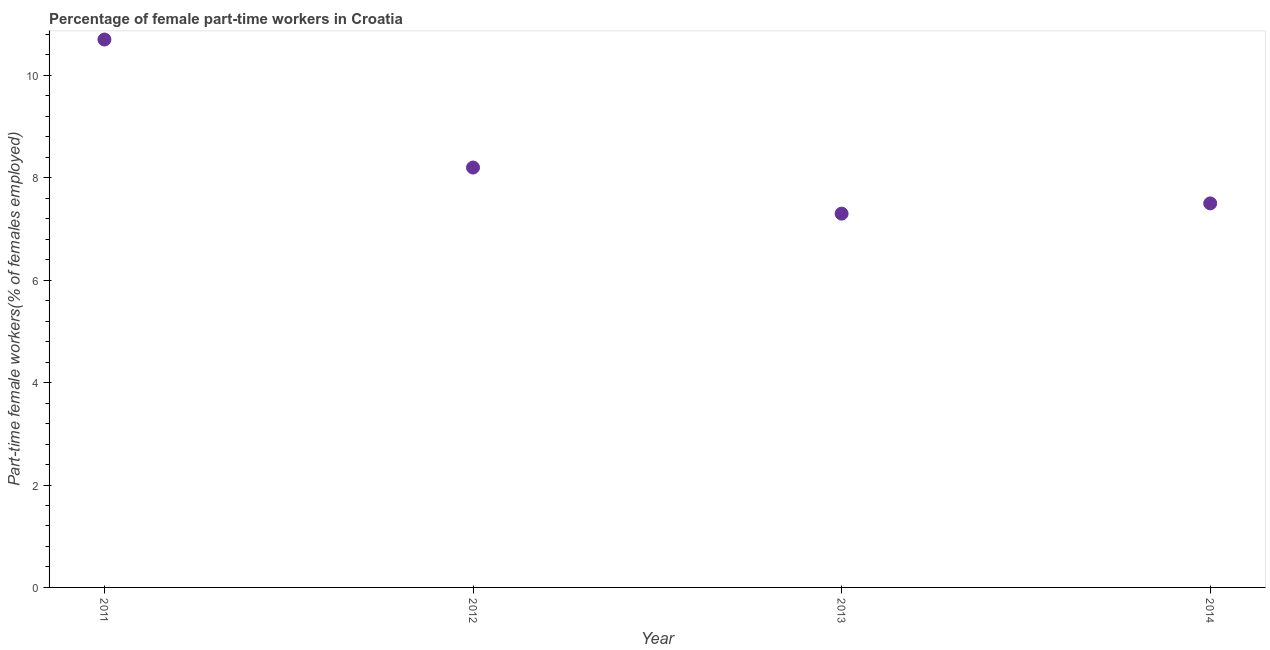What is the percentage of part-time female workers in 2012?
Offer a terse response. 8.2. Across all years, what is the maximum percentage of part-time female workers?
Keep it short and to the point. 10.7. Across all years, what is the minimum percentage of part-time female workers?
Keep it short and to the point. 7.3. In which year was the percentage of part-time female workers maximum?
Keep it short and to the point. 2011. In which year was the percentage of part-time female workers minimum?
Your answer should be very brief. 2013. What is the sum of the percentage of part-time female workers?
Offer a very short reply. 33.7. What is the difference between the percentage of part-time female workers in 2012 and 2013?
Keep it short and to the point. 0.9. What is the average percentage of part-time female workers per year?
Your response must be concise. 8.42. What is the median percentage of part-time female workers?
Provide a short and direct response. 7.85. Do a majority of the years between 2012 and 2014 (inclusive) have percentage of part-time female workers greater than 2.4 %?
Your response must be concise. Yes. What is the ratio of the percentage of part-time female workers in 2011 to that in 2012?
Your answer should be very brief. 1.3. Is the difference between the percentage of part-time female workers in 2011 and 2013 greater than the difference between any two years?
Give a very brief answer. Yes. What is the difference between the highest and the second highest percentage of part-time female workers?
Give a very brief answer. 2.5. Is the sum of the percentage of part-time female workers in 2012 and 2014 greater than the maximum percentage of part-time female workers across all years?
Ensure brevity in your answer.  Yes. What is the difference between the highest and the lowest percentage of part-time female workers?
Your answer should be very brief. 3.4. Does the percentage of part-time female workers monotonically increase over the years?
Provide a short and direct response. No. How many dotlines are there?
Provide a succinct answer. 1. What is the difference between two consecutive major ticks on the Y-axis?
Offer a terse response. 2. Are the values on the major ticks of Y-axis written in scientific E-notation?
Offer a very short reply. No. Does the graph contain any zero values?
Make the answer very short. No. Does the graph contain grids?
Your answer should be compact. No. What is the title of the graph?
Offer a terse response. Percentage of female part-time workers in Croatia. What is the label or title of the X-axis?
Provide a short and direct response. Year. What is the label or title of the Y-axis?
Offer a terse response. Part-time female workers(% of females employed). What is the Part-time female workers(% of females employed) in 2011?
Ensure brevity in your answer.  10.7. What is the Part-time female workers(% of females employed) in 2012?
Make the answer very short. 8.2. What is the Part-time female workers(% of females employed) in 2013?
Give a very brief answer. 7.3. What is the difference between the Part-time female workers(% of females employed) in 2011 and 2012?
Provide a succinct answer. 2.5. What is the difference between the Part-time female workers(% of females employed) in 2011 and 2014?
Provide a short and direct response. 3.2. What is the difference between the Part-time female workers(% of females employed) in 2012 and 2014?
Give a very brief answer. 0.7. What is the difference between the Part-time female workers(% of females employed) in 2013 and 2014?
Give a very brief answer. -0.2. What is the ratio of the Part-time female workers(% of females employed) in 2011 to that in 2012?
Offer a very short reply. 1.3. What is the ratio of the Part-time female workers(% of females employed) in 2011 to that in 2013?
Provide a short and direct response. 1.47. What is the ratio of the Part-time female workers(% of females employed) in 2011 to that in 2014?
Provide a succinct answer. 1.43. What is the ratio of the Part-time female workers(% of females employed) in 2012 to that in 2013?
Your answer should be very brief. 1.12. What is the ratio of the Part-time female workers(% of females employed) in 2012 to that in 2014?
Your response must be concise. 1.09. What is the ratio of the Part-time female workers(% of females employed) in 2013 to that in 2014?
Your response must be concise. 0.97. 